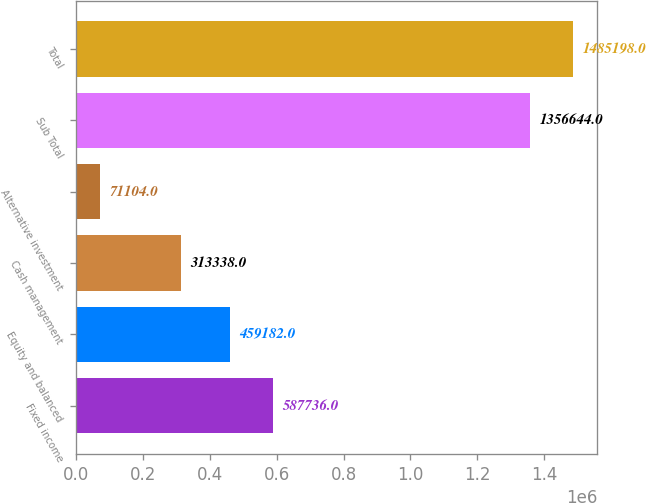Convert chart to OTSL. <chart><loc_0><loc_0><loc_500><loc_500><bar_chart><fcel>Fixed income<fcel>Equity and balanced<fcel>Cash management<fcel>Alternative investment<fcel>Sub Total<fcel>Total<nl><fcel>587736<fcel>459182<fcel>313338<fcel>71104<fcel>1.35664e+06<fcel>1.4852e+06<nl></chart> 